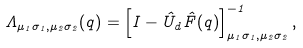<formula> <loc_0><loc_0><loc_500><loc_500>\Lambda _ { \mu _ { 1 } \sigma _ { 1 } , \mu _ { 2 } \sigma _ { 2 } } ( q ) = \left [ I - { \hat { U } } _ { d } { \hat { F } } ( q ) \right ] ^ { - 1 } _ { \mu _ { 1 } \sigma _ { 1 } , \mu _ { 2 } \sigma _ { 2 } } ,</formula> 